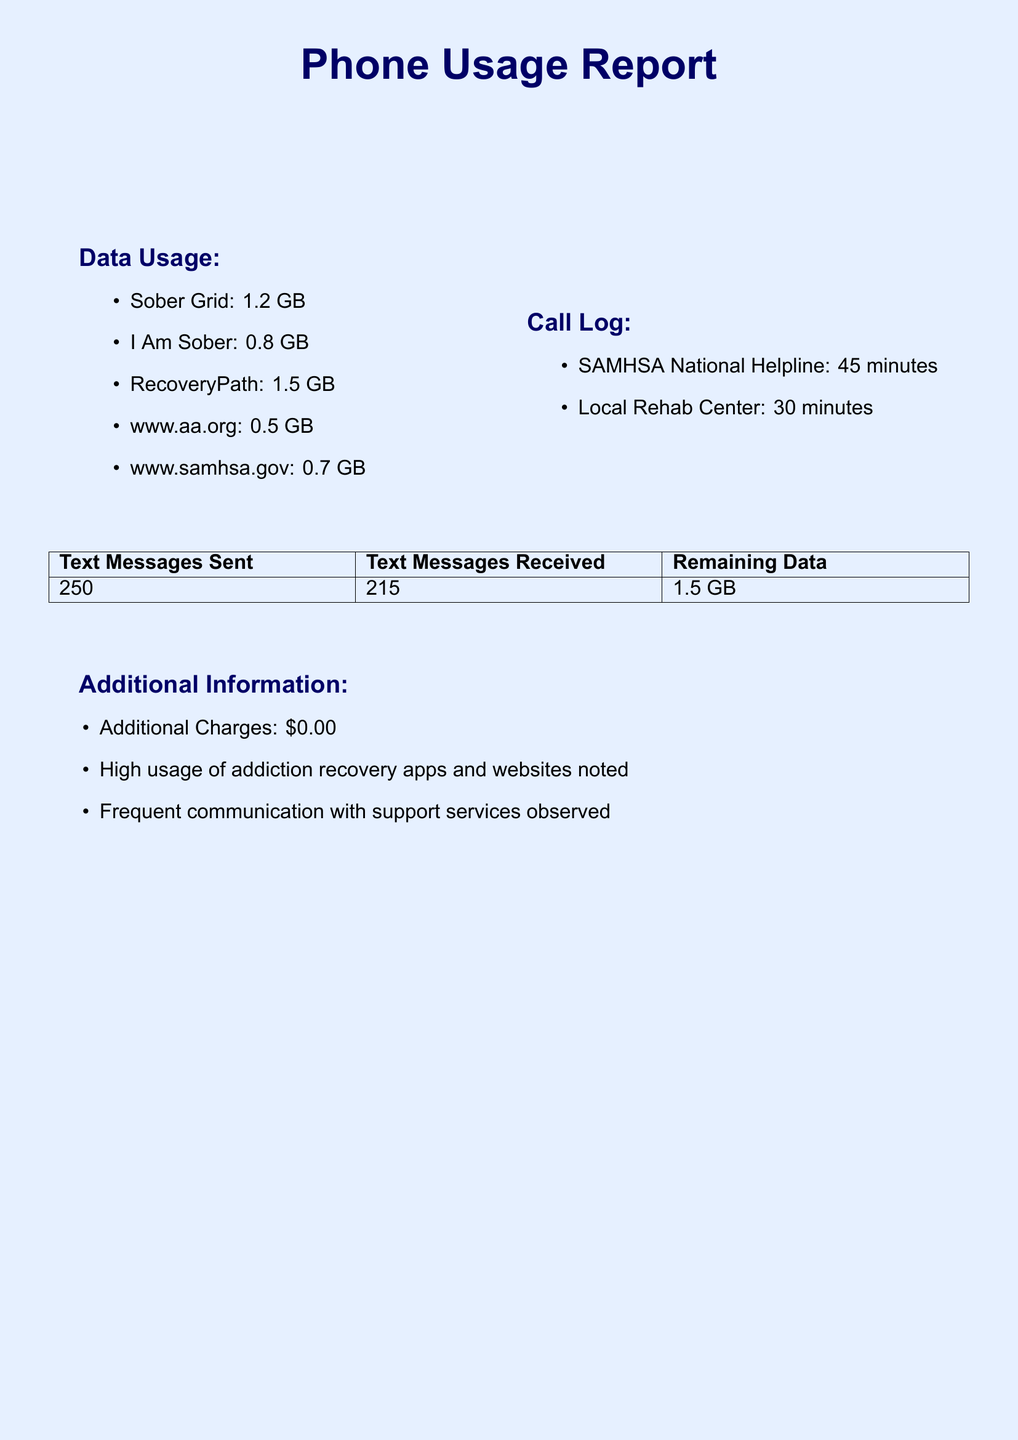What is the total data used? The total data used is specified in the document as 8.5 GB.
Answer: 8.5 GB How much data was used for RecoveryPath? The document lists the data usage for RecoveryPath as 1.5 GB.
Answer: 1.5 GB How many text messages were sent? The total number of text messages sent is provided in the document as 250.
Answer: 250 Who was called for 45 minutes? The call log in the document indicates that the SAMHSA National Helpline was called for 45 minutes.
Answer: SAMHSA National Helpline What is the remaining data after total usage? The document states the remaining data available is 1.5 GB.
Answer: 1.5 GB Which addiction recovery website used the most data? The document shows that Sober Grid used the most data, totaling 1.2 GB.
Answer: Sober Grid How many minutes were spent communicating with the Local Rehab Center? The document specifies that 30 minutes were spent communicating with the Local Rehab Center.
Answer: 30 minutes What type of phone plan is being used? The phone plan details mentioned in the document refer to an Unlimited Talk & Text with 10GB Data plan.
Answer: Unlimited Talk & Text with 10GB Data What additional charges were incurred? The document indicates that there were no additional charges incurred during the billing period.
Answer: $0.00 